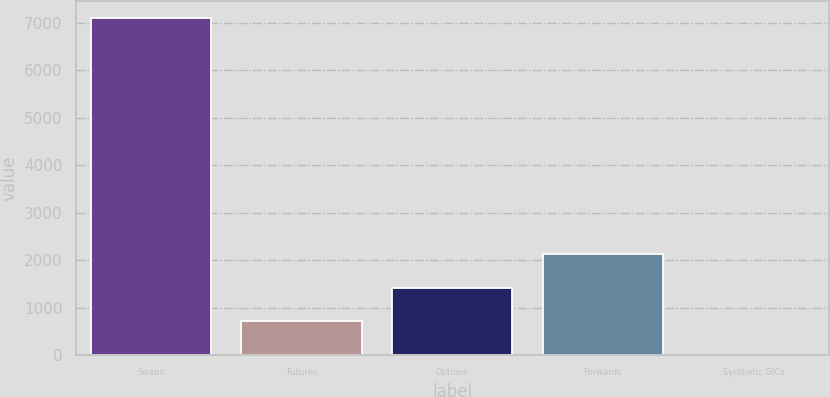Convert chart to OTSL. <chart><loc_0><loc_0><loc_500><loc_500><bar_chart><fcel>Swaps<fcel>Futures<fcel>Options<fcel>Forwards<fcel>Synthetic GICs<nl><fcel>7097<fcel>714.2<fcel>1423.4<fcel>2132.6<fcel>5<nl></chart> 